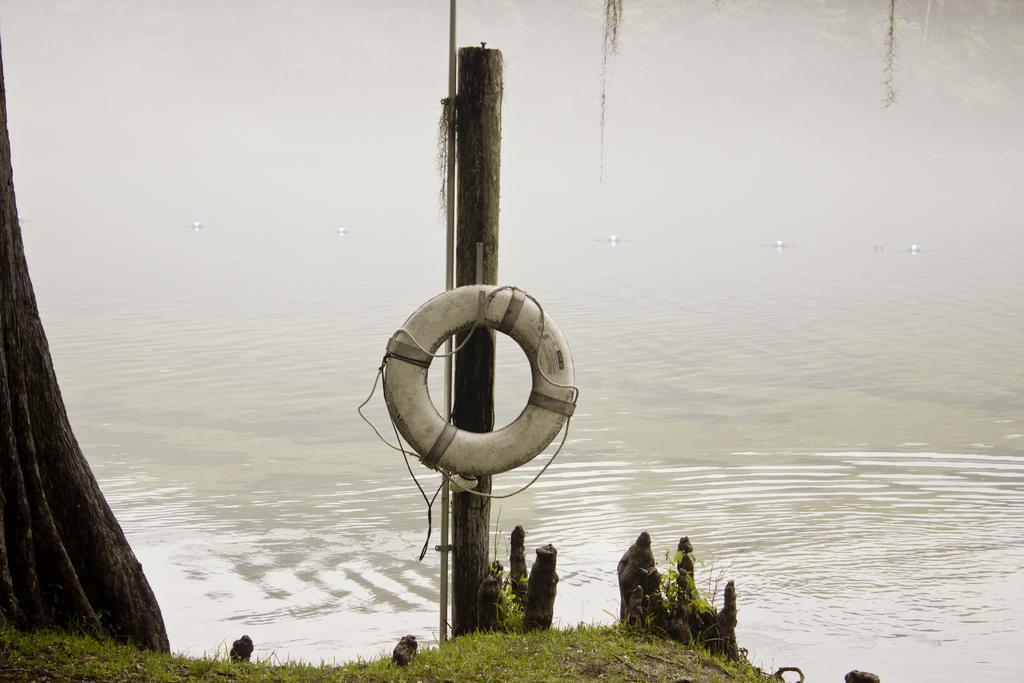Can you describe this image briefly? In this image, in the middle, we can see a wood pole and a tube which is attached to a wood pole. On the left side, we can see a wooden trunk. In the background, we can see a water in a lake and a grass. 